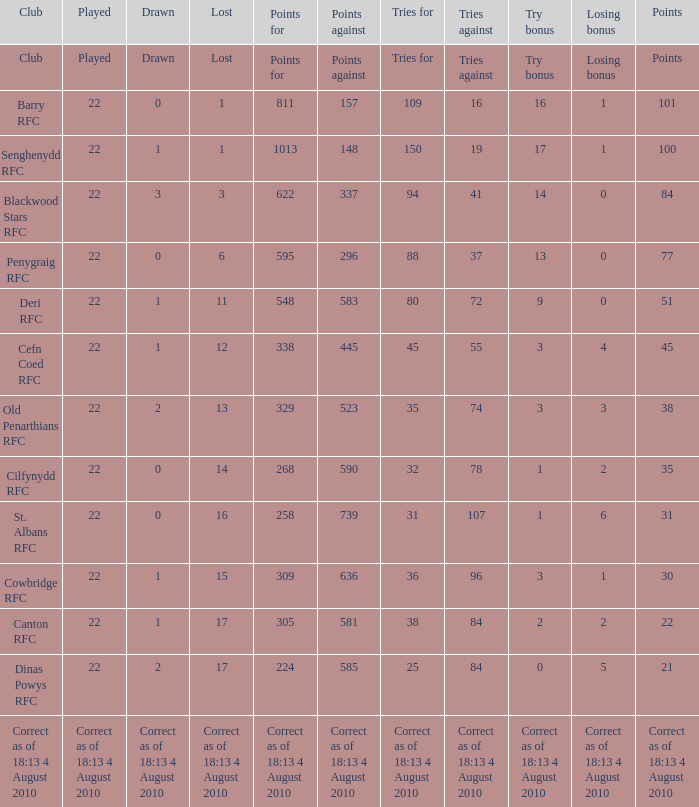What is the name of the club when the played number is 22, and the try bonus was 0? Dinas Powys RFC. Help me parse the entirety of this table. {'header': ['Club', 'Played', 'Drawn', 'Lost', 'Points for', 'Points against', 'Tries for', 'Tries against', 'Try bonus', 'Losing bonus', 'Points'], 'rows': [['Club', 'Played', 'Drawn', 'Lost', 'Points for', 'Points against', 'Tries for', 'Tries against', 'Try bonus', 'Losing bonus', 'Points'], ['Barry RFC', '22', '0', '1', '811', '157', '109', '16', '16', '1', '101'], ['Senghenydd RFC', '22', '1', '1', '1013', '148', '150', '19', '17', '1', '100'], ['Blackwood Stars RFC', '22', '3', '3', '622', '337', '94', '41', '14', '0', '84'], ['Penygraig RFC', '22', '0', '6', '595', '296', '88', '37', '13', '0', '77'], ['Deri RFC', '22', '1', '11', '548', '583', '80', '72', '9', '0', '51'], ['Cefn Coed RFC', '22', '1', '12', '338', '445', '45', '55', '3', '4', '45'], ['Old Penarthians RFC', '22', '2', '13', '329', '523', '35', '74', '3', '3', '38'], ['Cilfynydd RFC', '22', '0', '14', '268', '590', '32', '78', '1', '2', '35'], ['St. Albans RFC', '22', '0', '16', '258', '739', '31', '107', '1', '6', '31'], ['Cowbridge RFC', '22', '1', '15', '309', '636', '36', '96', '3', '1', '30'], ['Canton RFC', '22', '1', '17', '305', '581', '38', '84', '2', '2', '22'], ['Dinas Powys RFC', '22', '2', '17', '224', '585', '25', '84', '0', '5', '21'], ['Correct as of 18:13 4 August 2010', 'Correct as of 18:13 4 August 2010', 'Correct as of 18:13 4 August 2010', 'Correct as of 18:13 4 August 2010', 'Correct as of 18:13 4 August 2010', 'Correct as of 18:13 4 August 2010', 'Correct as of 18:13 4 August 2010', 'Correct as of 18:13 4 August 2010', 'Correct as of 18:13 4 August 2010', 'Correct as of 18:13 4 August 2010', 'Correct as of 18:13 4 August 2010']]} 